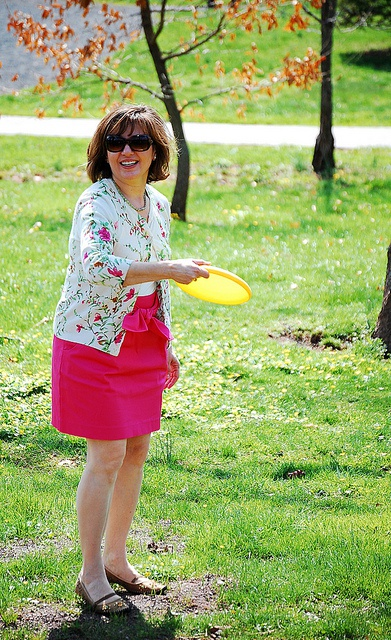Describe the objects in this image and their specific colors. I can see people in gray, lightgray, brown, and darkgray tones and frisbee in gray, khaki, yellow, gold, and ivory tones in this image. 